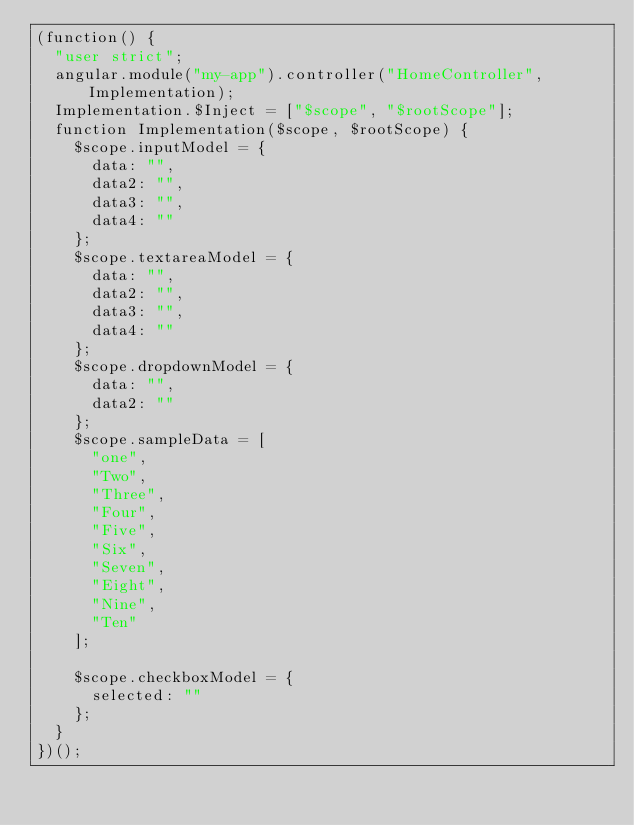<code> <loc_0><loc_0><loc_500><loc_500><_JavaScript_>(function() {
  "user strict";
  angular.module("my-app").controller("HomeController", Implementation);
  Implementation.$Inject = ["$scope", "$rootScope"];
  function Implementation($scope, $rootScope) {
    $scope.inputModel = {
      data: "",
      data2: "",
      data3: "",
      data4: ""
    };
    $scope.textareaModel = {
      data: "",
      data2: "",
      data3: "",
      data4: ""
    };
    $scope.dropdownModel = {
      data: "",
      data2: ""
    };
    $scope.sampleData = [
      "one",
      "Two",
      "Three",
      "Four",
      "Five",
      "Six",
      "Seven",
      "Eight",
      "Nine",
      "Ten"
    ];

    $scope.checkboxModel = {
      selected: ""
    };
  }
})();
</code> 